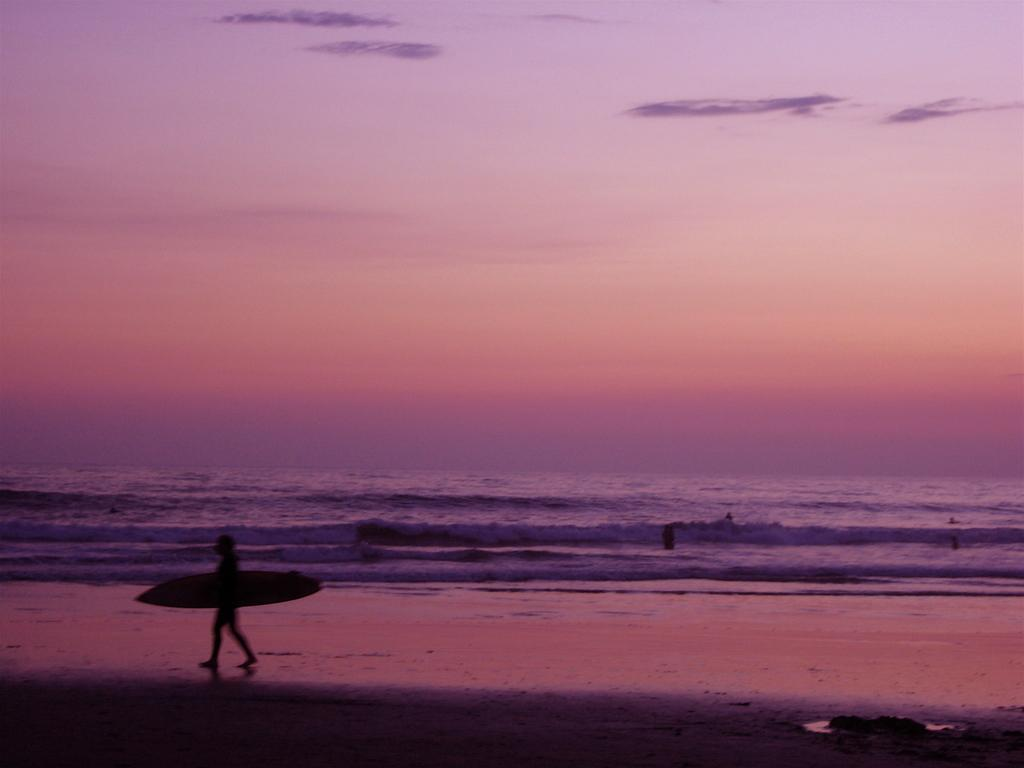What is the person in the image doing? The person is holding a surfboard and walking on the beach. What object is the person holding in the image? The person is holding a surfboard. What type of terrain is visible in the background of the image? There is water visible in the background of the image. What is the color of the sky in the image? The sky is pink in color. What type of cheese can be seen on the slope in the image? There is no cheese or slope present in the image. How many parcels are visible on the beach in the image? There are no parcels visible in the image; it only shows a person holding a surfboard and walking on the beach. 